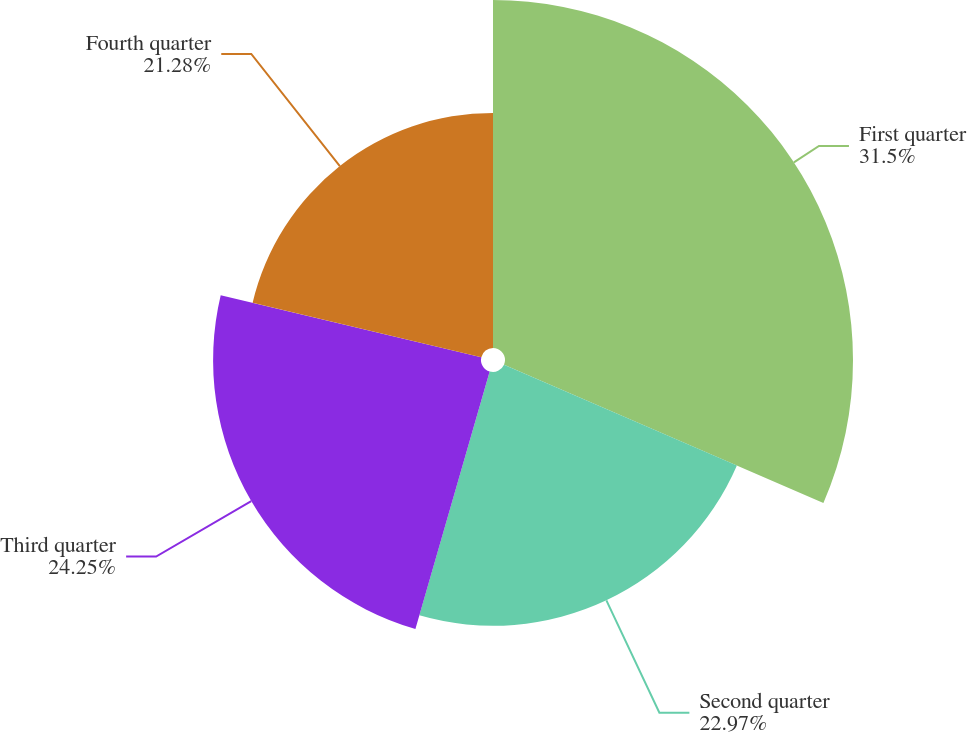<chart> <loc_0><loc_0><loc_500><loc_500><pie_chart><fcel>First quarter<fcel>Second quarter<fcel>Third quarter<fcel>Fourth quarter<nl><fcel>31.5%<fcel>22.97%<fcel>24.25%<fcel>21.28%<nl></chart> 